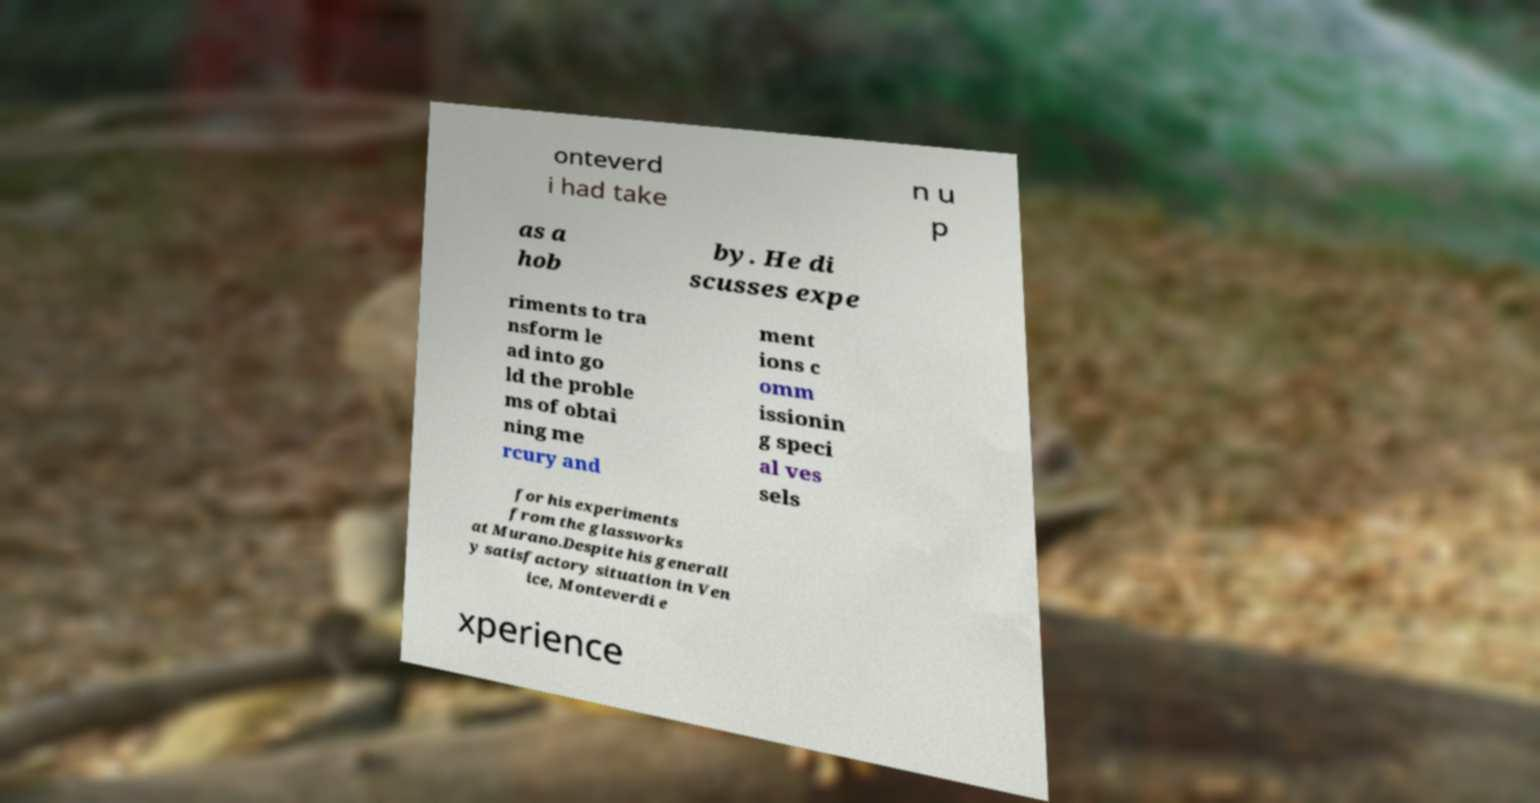Can you accurately transcribe the text from the provided image for me? onteverd i had take n u p as a hob by. He di scusses expe riments to tra nsform le ad into go ld the proble ms of obtai ning me rcury and ment ions c omm issionin g speci al ves sels for his experiments from the glassworks at Murano.Despite his generall y satisfactory situation in Ven ice, Monteverdi e xperience 